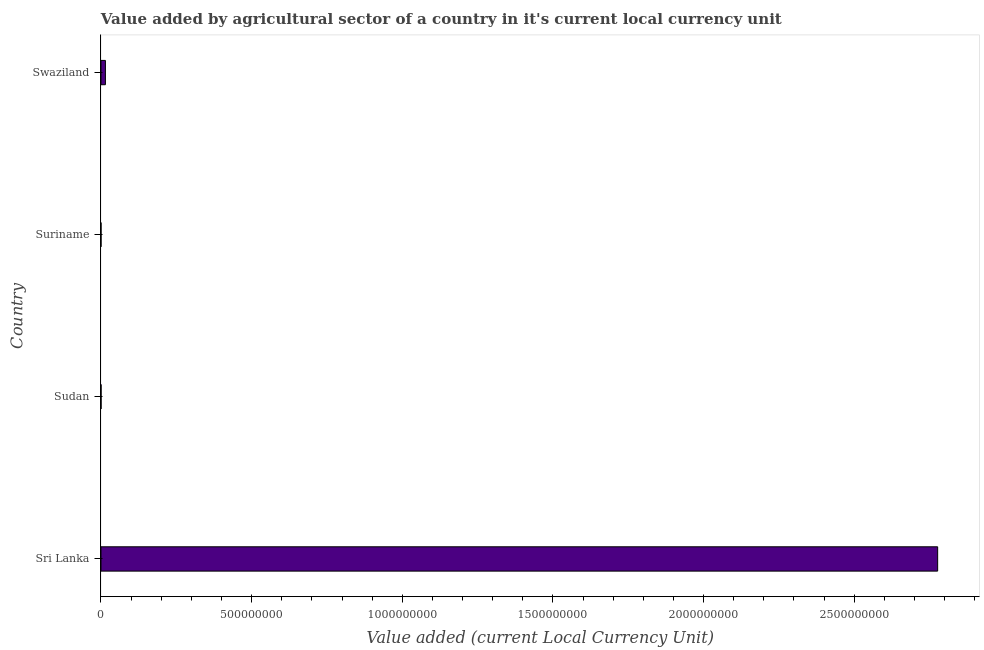Does the graph contain grids?
Ensure brevity in your answer.  No. What is the title of the graph?
Offer a terse response. Value added by agricultural sector of a country in it's current local currency unit. What is the label or title of the X-axis?
Make the answer very short. Value added (current Local Currency Unit). What is the value added by agriculture sector in Suriname?
Give a very brief answer. 3.45e+04. Across all countries, what is the maximum value added by agriculture sector?
Offer a terse response. 2.78e+09. Across all countries, what is the minimum value added by agriculture sector?
Provide a succinct answer. 3.45e+04. In which country was the value added by agriculture sector maximum?
Your response must be concise. Sri Lanka. In which country was the value added by agriculture sector minimum?
Provide a succinct answer. Suriname. What is the sum of the value added by agriculture sector?
Offer a terse response. 2.79e+09. What is the difference between the value added by agriculture sector in Sudan and Suriname?
Keep it short and to the point. 1.61e+05. What is the average value added by agriculture sector per country?
Your response must be concise. 6.98e+08. What is the median value added by agriculture sector?
Provide a succinct answer. 7.45e+06. In how many countries, is the value added by agriculture sector greater than 200000000 LCU?
Offer a terse response. 1. What is the ratio of the value added by agriculture sector in Sri Lanka to that in Swaziland?
Keep it short and to the point. 188.91. Is the difference between the value added by agriculture sector in Suriname and Swaziland greater than the difference between any two countries?
Offer a terse response. No. What is the difference between the highest and the second highest value added by agriculture sector?
Offer a terse response. 2.76e+09. What is the difference between the highest and the lowest value added by agriculture sector?
Offer a terse response. 2.78e+09. In how many countries, is the value added by agriculture sector greater than the average value added by agriculture sector taken over all countries?
Offer a terse response. 1. How many bars are there?
Provide a short and direct response. 4. Are all the bars in the graph horizontal?
Your answer should be compact. Yes. What is the Value added (current Local Currency Unit) in Sri Lanka?
Your answer should be compact. 2.78e+09. What is the Value added (current Local Currency Unit) in Sudan?
Your response must be concise. 1.95e+05. What is the Value added (current Local Currency Unit) in Suriname?
Your answer should be very brief. 3.45e+04. What is the Value added (current Local Currency Unit) of Swaziland?
Ensure brevity in your answer.  1.47e+07. What is the difference between the Value added (current Local Currency Unit) in Sri Lanka and Sudan?
Your answer should be very brief. 2.78e+09. What is the difference between the Value added (current Local Currency Unit) in Sri Lanka and Suriname?
Keep it short and to the point. 2.78e+09. What is the difference between the Value added (current Local Currency Unit) in Sri Lanka and Swaziland?
Your answer should be very brief. 2.76e+09. What is the difference between the Value added (current Local Currency Unit) in Sudan and Suriname?
Give a very brief answer. 1.61e+05. What is the difference between the Value added (current Local Currency Unit) in Sudan and Swaziland?
Offer a very short reply. -1.45e+07. What is the difference between the Value added (current Local Currency Unit) in Suriname and Swaziland?
Keep it short and to the point. -1.47e+07. What is the ratio of the Value added (current Local Currency Unit) in Sri Lanka to that in Sudan?
Offer a very short reply. 1.42e+04. What is the ratio of the Value added (current Local Currency Unit) in Sri Lanka to that in Suriname?
Provide a short and direct response. 8.05e+04. What is the ratio of the Value added (current Local Currency Unit) in Sri Lanka to that in Swaziland?
Your answer should be very brief. 188.91. What is the ratio of the Value added (current Local Currency Unit) in Sudan to that in Suriname?
Offer a terse response. 5.66. What is the ratio of the Value added (current Local Currency Unit) in Sudan to that in Swaziland?
Your response must be concise. 0.01. What is the ratio of the Value added (current Local Currency Unit) in Suriname to that in Swaziland?
Give a very brief answer. 0. 